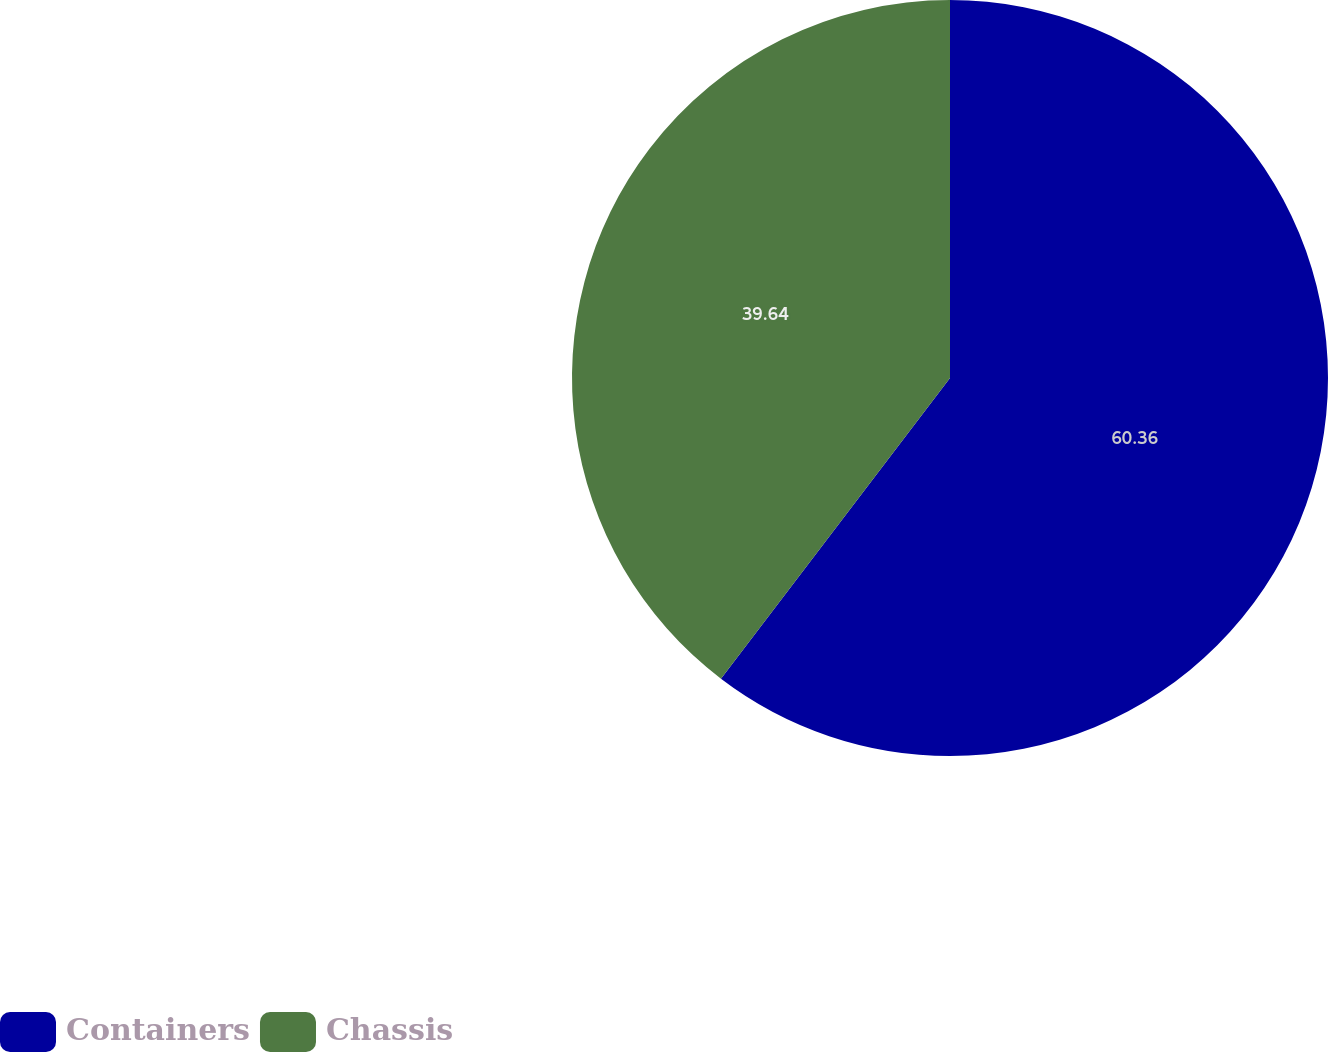Convert chart. <chart><loc_0><loc_0><loc_500><loc_500><pie_chart><fcel>Containers<fcel>Chassis<nl><fcel>60.36%<fcel>39.64%<nl></chart> 